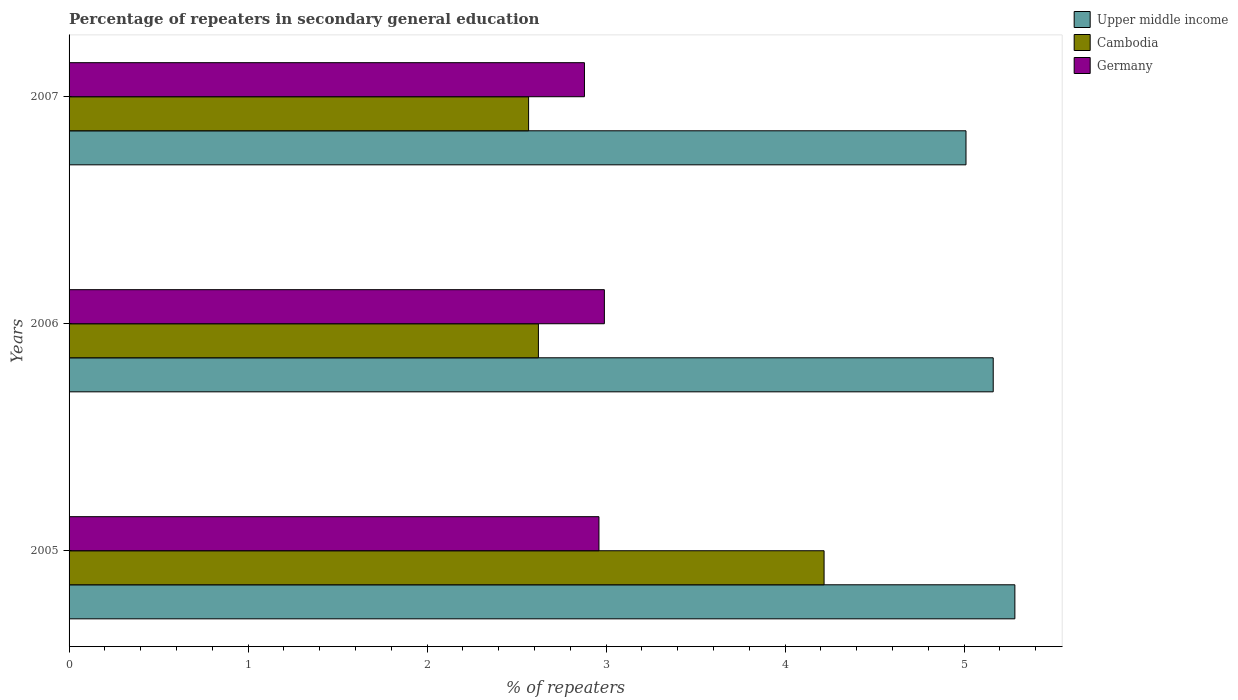How many different coloured bars are there?
Ensure brevity in your answer.  3. How many groups of bars are there?
Give a very brief answer. 3. What is the label of the 3rd group of bars from the top?
Keep it short and to the point. 2005. What is the percentage of repeaters in secondary general education in Germany in 2005?
Provide a succinct answer. 2.96. Across all years, what is the maximum percentage of repeaters in secondary general education in Cambodia?
Make the answer very short. 4.22. Across all years, what is the minimum percentage of repeaters in secondary general education in Germany?
Your answer should be compact. 2.88. In which year was the percentage of repeaters in secondary general education in Upper middle income maximum?
Offer a very short reply. 2005. In which year was the percentage of repeaters in secondary general education in Upper middle income minimum?
Ensure brevity in your answer.  2007. What is the total percentage of repeaters in secondary general education in Cambodia in the graph?
Provide a short and direct response. 9.41. What is the difference between the percentage of repeaters in secondary general education in Cambodia in 2005 and that in 2006?
Your answer should be compact. 1.6. What is the difference between the percentage of repeaters in secondary general education in Cambodia in 2005 and the percentage of repeaters in secondary general education in Upper middle income in 2007?
Offer a terse response. -0.79. What is the average percentage of repeaters in secondary general education in Cambodia per year?
Provide a succinct answer. 3.14. In the year 2006, what is the difference between the percentage of repeaters in secondary general education in Upper middle income and percentage of repeaters in secondary general education in Cambodia?
Your answer should be compact. 2.54. In how many years, is the percentage of repeaters in secondary general education in Upper middle income greater than 4.2 %?
Provide a succinct answer. 3. What is the ratio of the percentage of repeaters in secondary general education in Upper middle income in 2005 to that in 2006?
Give a very brief answer. 1.02. Is the difference between the percentage of repeaters in secondary general education in Upper middle income in 2005 and 2007 greater than the difference between the percentage of repeaters in secondary general education in Cambodia in 2005 and 2007?
Your answer should be compact. No. What is the difference between the highest and the second highest percentage of repeaters in secondary general education in Upper middle income?
Offer a terse response. 0.12. What is the difference between the highest and the lowest percentage of repeaters in secondary general education in Cambodia?
Offer a very short reply. 1.65. What does the 3rd bar from the top in 2005 represents?
Your answer should be compact. Upper middle income. What does the 2nd bar from the bottom in 2007 represents?
Provide a succinct answer. Cambodia. Is it the case that in every year, the sum of the percentage of repeaters in secondary general education in Upper middle income and percentage of repeaters in secondary general education in Germany is greater than the percentage of repeaters in secondary general education in Cambodia?
Your response must be concise. Yes. Are all the bars in the graph horizontal?
Keep it short and to the point. Yes. How many years are there in the graph?
Give a very brief answer. 3. What is the difference between two consecutive major ticks on the X-axis?
Your response must be concise. 1. How many legend labels are there?
Give a very brief answer. 3. What is the title of the graph?
Your answer should be very brief. Percentage of repeaters in secondary general education. Does "Belize" appear as one of the legend labels in the graph?
Keep it short and to the point. No. What is the label or title of the X-axis?
Your response must be concise. % of repeaters. What is the % of repeaters in Upper middle income in 2005?
Keep it short and to the point. 5.28. What is the % of repeaters of Cambodia in 2005?
Keep it short and to the point. 4.22. What is the % of repeaters in Germany in 2005?
Keep it short and to the point. 2.96. What is the % of repeaters of Upper middle income in 2006?
Your answer should be compact. 5.16. What is the % of repeaters of Cambodia in 2006?
Keep it short and to the point. 2.62. What is the % of repeaters of Germany in 2006?
Ensure brevity in your answer.  2.99. What is the % of repeaters of Upper middle income in 2007?
Make the answer very short. 5.01. What is the % of repeaters of Cambodia in 2007?
Give a very brief answer. 2.57. What is the % of repeaters in Germany in 2007?
Your response must be concise. 2.88. Across all years, what is the maximum % of repeaters of Upper middle income?
Make the answer very short. 5.28. Across all years, what is the maximum % of repeaters in Cambodia?
Your answer should be very brief. 4.22. Across all years, what is the maximum % of repeaters of Germany?
Your response must be concise. 2.99. Across all years, what is the minimum % of repeaters in Upper middle income?
Your response must be concise. 5.01. Across all years, what is the minimum % of repeaters in Cambodia?
Offer a very short reply. 2.57. Across all years, what is the minimum % of repeaters of Germany?
Provide a short and direct response. 2.88. What is the total % of repeaters of Upper middle income in the graph?
Your answer should be very brief. 15.46. What is the total % of repeaters in Cambodia in the graph?
Keep it short and to the point. 9.41. What is the total % of repeaters of Germany in the graph?
Offer a terse response. 8.83. What is the difference between the % of repeaters of Upper middle income in 2005 and that in 2006?
Offer a terse response. 0.12. What is the difference between the % of repeaters in Cambodia in 2005 and that in 2006?
Ensure brevity in your answer.  1.6. What is the difference between the % of repeaters of Germany in 2005 and that in 2006?
Provide a short and direct response. -0.03. What is the difference between the % of repeaters in Upper middle income in 2005 and that in 2007?
Keep it short and to the point. 0.27. What is the difference between the % of repeaters in Cambodia in 2005 and that in 2007?
Make the answer very short. 1.65. What is the difference between the % of repeaters of Germany in 2005 and that in 2007?
Offer a very short reply. 0.08. What is the difference between the % of repeaters of Upper middle income in 2006 and that in 2007?
Offer a terse response. 0.15. What is the difference between the % of repeaters in Cambodia in 2006 and that in 2007?
Give a very brief answer. 0.05. What is the difference between the % of repeaters in Germany in 2006 and that in 2007?
Your answer should be compact. 0.11. What is the difference between the % of repeaters in Upper middle income in 2005 and the % of repeaters in Cambodia in 2006?
Your answer should be very brief. 2.66. What is the difference between the % of repeaters of Upper middle income in 2005 and the % of repeaters of Germany in 2006?
Your response must be concise. 2.29. What is the difference between the % of repeaters in Cambodia in 2005 and the % of repeaters in Germany in 2006?
Offer a very short reply. 1.23. What is the difference between the % of repeaters of Upper middle income in 2005 and the % of repeaters of Cambodia in 2007?
Offer a terse response. 2.72. What is the difference between the % of repeaters of Upper middle income in 2005 and the % of repeaters of Germany in 2007?
Make the answer very short. 2.4. What is the difference between the % of repeaters in Cambodia in 2005 and the % of repeaters in Germany in 2007?
Provide a short and direct response. 1.34. What is the difference between the % of repeaters in Upper middle income in 2006 and the % of repeaters in Cambodia in 2007?
Keep it short and to the point. 2.6. What is the difference between the % of repeaters of Upper middle income in 2006 and the % of repeaters of Germany in 2007?
Make the answer very short. 2.28. What is the difference between the % of repeaters in Cambodia in 2006 and the % of repeaters in Germany in 2007?
Your response must be concise. -0.26. What is the average % of repeaters in Upper middle income per year?
Ensure brevity in your answer.  5.15. What is the average % of repeaters of Cambodia per year?
Offer a terse response. 3.14. What is the average % of repeaters of Germany per year?
Your answer should be compact. 2.94. In the year 2005, what is the difference between the % of repeaters in Upper middle income and % of repeaters in Cambodia?
Provide a short and direct response. 1.07. In the year 2005, what is the difference between the % of repeaters of Upper middle income and % of repeaters of Germany?
Offer a very short reply. 2.32. In the year 2005, what is the difference between the % of repeaters of Cambodia and % of repeaters of Germany?
Make the answer very short. 1.26. In the year 2006, what is the difference between the % of repeaters in Upper middle income and % of repeaters in Cambodia?
Your answer should be compact. 2.54. In the year 2006, what is the difference between the % of repeaters of Upper middle income and % of repeaters of Germany?
Ensure brevity in your answer.  2.17. In the year 2006, what is the difference between the % of repeaters of Cambodia and % of repeaters of Germany?
Your response must be concise. -0.37. In the year 2007, what is the difference between the % of repeaters of Upper middle income and % of repeaters of Cambodia?
Ensure brevity in your answer.  2.44. In the year 2007, what is the difference between the % of repeaters of Upper middle income and % of repeaters of Germany?
Ensure brevity in your answer.  2.13. In the year 2007, what is the difference between the % of repeaters of Cambodia and % of repeaters of Germany?
Your answer should be compact. -0.31. What is the ratio of the % of repeaters of Upper middle income in 2005 to that in 2006?
Offer a very short reply. 1.02. What is the ratio of the % of repeaters in Cambodia in 2005 to that in 2006?
Provide a short and direct response. 1.61. What is the ratio of the % of repeaters in Germany in 2005 to that in 2006?
Your response must be concise. 0.99. What is the ratio of the % of repeaters of Upper middle income in 2005 to that in 2007?
Ensure brevity in your answer.  1.05. What is the ratio of the % of repeaters of Cambodia in 2005 to that in 2007?
Make the answer very short. 1.64. What is the ratio of the % of repeaters of Germany in 2005 to that in 2007?
Keep it short and to the point. 1.03. What is the ratio of the % of repeaters in Upper middle income in 2006 to that in 2007?
Make the answer very short. 1.03. What is the ratio of the % of repeaters of Cambodia in 2006 to that in 2007?
Make the answer very short. 1.02. What is the ratio of the % of repeaters of Germany in 2006 to that in 2007?
Make the answer very short. 1.04. What is the difference between the highest and the second highest % of repeaters in Upper middle income?
Keep it short and to the point. 0.12. What is the difference between the highest and the second highest % of repeaters of Cambodia?
Provide a succinct answer. 1.6. What is the difference between the highest and the second highest % of repeaters in Germany?
Make the answer very short. 0.03. What is the difference between the highest and the lowest % of repeaters of Upper middle income?
Offer a very short reply. 0.27. What is the difference between the highest and the lowest % of repeaters of Cambodia?
Provide a short and direct response. 1.65. What is the difference between the highest and the lowest % of repeaters in Germany?
Provide a succinct answer. 0.11. 